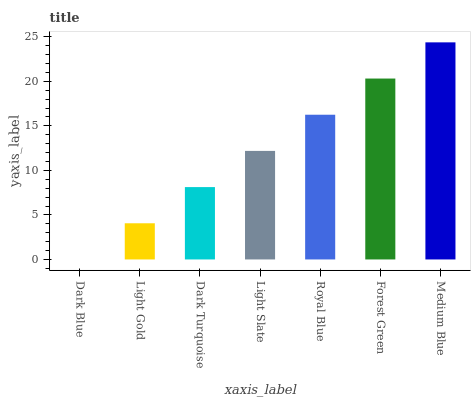Is Dark Blue the minimum?
Answer yes or no. Yes. Is Medium Blue the maximum?
Answer yes or no. Yes. Is Light Gold the minimum?
Answer yes or no. No. Is Light Gold the maximum?
Answer yes or no. No. Is Light Gold greater than Dark Blue?
Answer yes or no. Yes. Is Dark Blue less than Light Gold?
Answer yes or no. Yes. Is Dark Blue greater than Light Gold?
Answer yes or no. No. Is Light Gold less than Dark Blue?
Answer yes or no. No. Is Light Slate the high median?
Answer yes or no. Yes. Is Light Slate the low median?
Answer yes or no. Yes. Is Medium Blue the high median?
Answer yes or no. No. Is Light Gold the low median?
Answer yes or no. No. 